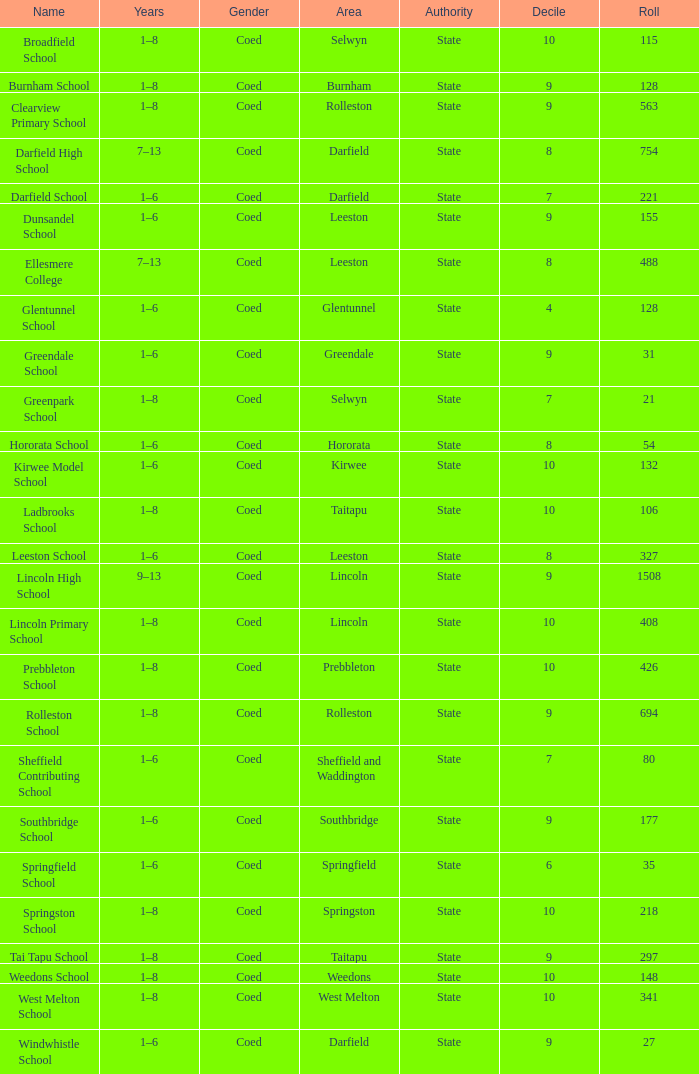Can you parse all the data within this table? {'header': ['Name', 'Years', 'Gender', 'Area', 'Authority', 'Decile', 'Roll'], 'rows': [['Broadfield School', '1–8', 'Coed', 'Selwyn', 'State', '10', '115'], ['Burnham School', '1–8', 'Coed', 'Burnham', 'State', '9', '128'], ['Clearview Primary School', '1–8', 'Coed', 'Rolleston', 'State', '9', '563'], ['Darfield High School', '7–13', 'Coed', 'Darfield', 'State', '8', '754'], ['Darfield School', '1–6', 'Coed', 'Darfield', 'State', '7', '221'], ['Dunsandel School', '1–6', 'Coed', 'Leeston', 'State', '9', '155'], ['Ellesmere College', '7–13', 'Coed', 'Leeston', 'State', '8', '488'], ['Glentunnel School', '1–6', 'Coed', 'Glentunnel', 'State', '4', '128'], ['Greendale School', '1–6', 'Coed', 'Greendale', 'State', '9', '31'], ['Greenpark School', '1–8', 'Coed', 'Selwyn', 'State', '7', '21'], ['Hororata School', '1–6', 'Coed', 'Hororata', 'State', '8', '54'], ['Kirwee Model School', '1–6', 'Coed', 'Kirwee', 'State', '10', '132'], ['Ladbrooks School', '1–8', 'Coed', 'Taitapu', 'State', '10', '106'], ['Leeston School', '1–6', 'Coed', 'Leeston', 'State', '8', '327'], ['Lincoln High School', '9–13', 'Coed', 'Lincoln', 'State', '9', '1508'], ['Lincoln Primary School', '1–8', 'Coed', 'Lincoln', 'State', '10', '408'], ['Prebbleton School', '1–8', 'Coed', 'Prebbleton', 'State', '10', '426'], ['Rolleston School', '1–8', 'Coed', 'Rolleston', 'State', '9', '694'], ['Sheffield Contributing School', '1–6', 'Coed', 'Sheffield and Waddington', 'State', '7', '80'], ['Southbridge School', '1–6', 'Coed', 'Southbridge', 'State', '9', '177'], ['Springfield School', '1–6', 'Coed', 'Springfield', 'State', '6', '35'], ['Springston School', '1–8', 'Coed', 'Springston', 'State', '10', '218'], ['Tai Tapu School', '1–8', 'Coed', 'Taitapu', 'State', '9', '297'], ['Weedons School', '1–8', 'Coed', 'Weedons', 'State', '10', '148'], ['West Melton School', '1–8', 'Coed', 'West Melton', 'State', '10', '341'], ['Windwhistle School', '1–6', 'Coed', 'Darfield', 'State', '9', '27']]} Calculate the total roll for a school with an 8 decile rating in the hororata region. 54.0. 